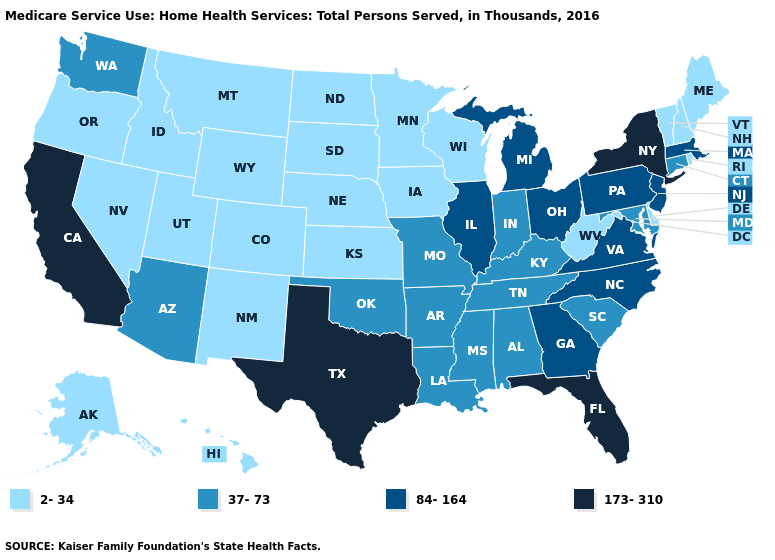Name the states that have a value in the range 173-310?
Be succinct. California, Florida, New York, Texas. Name the states that have a value in the range 2-34?
Keep it brief. Alaska, Colorado, Delaware, Hawaii, Idaho, Iowa, Kansas, Maine, Minnesota, Montana, Nebraska, Nevada, New Hampshire, New Mexico, North Dakota, Oregon, Rhode Island, South Dakota, Utah, Vermont, West Virginia, Wisconsin, Wyoming. Is the legend a continuous bar?
Concise answer only. No. Among the states that border Oklahoma , does Kansas have the highest value?
Keep it brief. No. Which states have the lowest value in the USA?
Quick response, please. Alaska, Colorado, Delaware, Hawaii, Idaho, Iowa, Kansas, Maine, Minnesota, Montana, Nebraska, Nevada, New Hampshire, New Mexico, North Dakota, Oregon, Rhode Island, South Dakota, Utah, Vermont, West Virginia, Wisconsin, Wyoming. What is the highest value in the USA?
Quick response, please. 173-310. Among the states that border Washington , which have the highest value?
Keep it brief. Idaho, Oregon. What is the lowest value in the USA?
Quick response, please. 2-34. What is the highest value in the USA?
Answer briefly. 173-310. How many symbols are there in the legend?
Quick response, please. 4. Name the states that have a value in the range 37-73?
Short answer required. Alabama, Arizona, Arkansas, Connecticut, Indiana, Kentucky, Louisiana, Maryland, Mississippi, Missouri, Oklahoma, South Carolina, Tennessee, Washington. What is the value of Connecticut?
Keep it brief. 37-73. Among the states that border Nevada , which have the lowest value?
Quick response, please. Idaho, Oregon, Utah. Name the states that have a value in the range 84-164?
Give a very brief answer. Georgia, Illinois, Massachusetts, Michigan, New Jersey, North Carolina, Ohio, Pennsylvania, Virginia. Does New York have the same value as Kansas?
Quick response, please. No. 